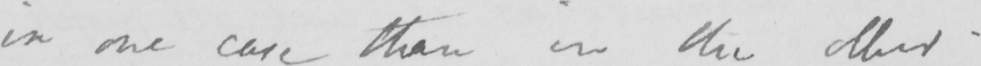Can you tell me what this handwritten text says? in the one case than in the other . 